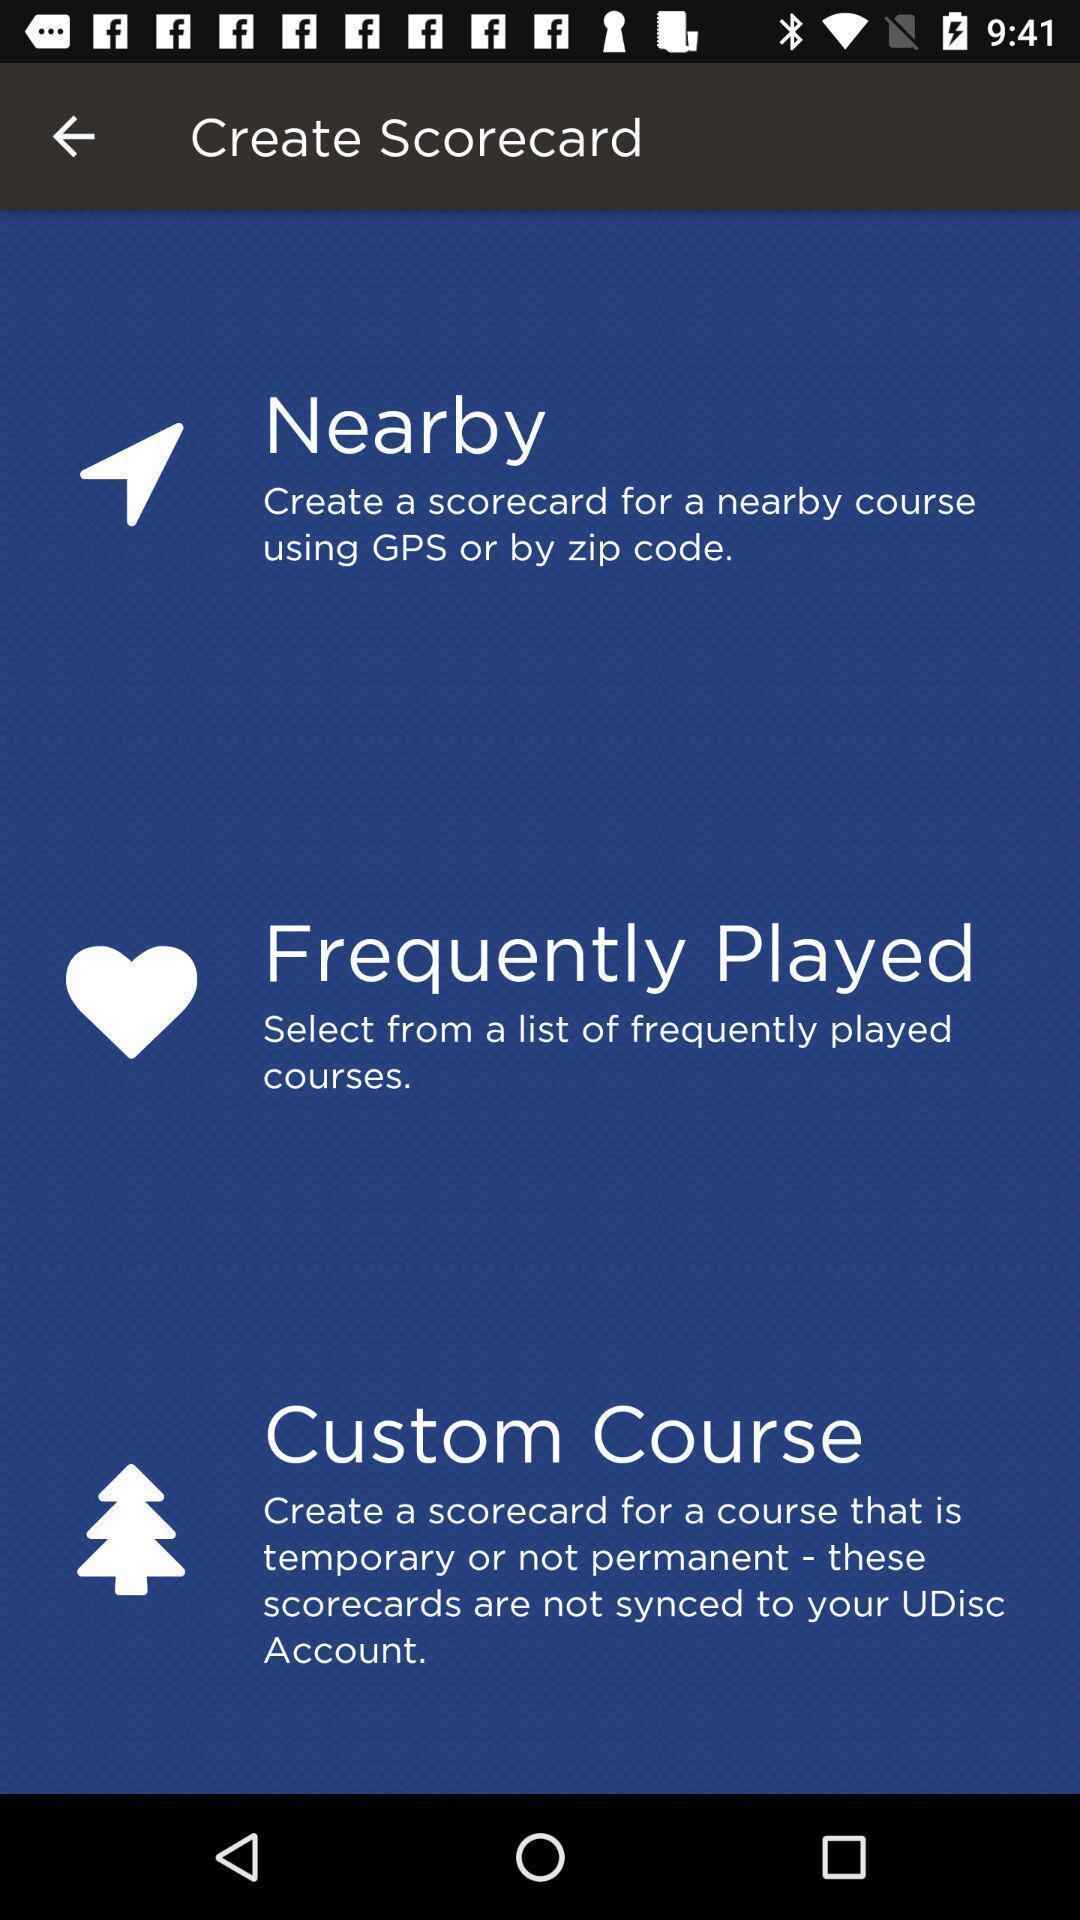Tell me what you see in this picture. Page is showing options to create scorecard. 